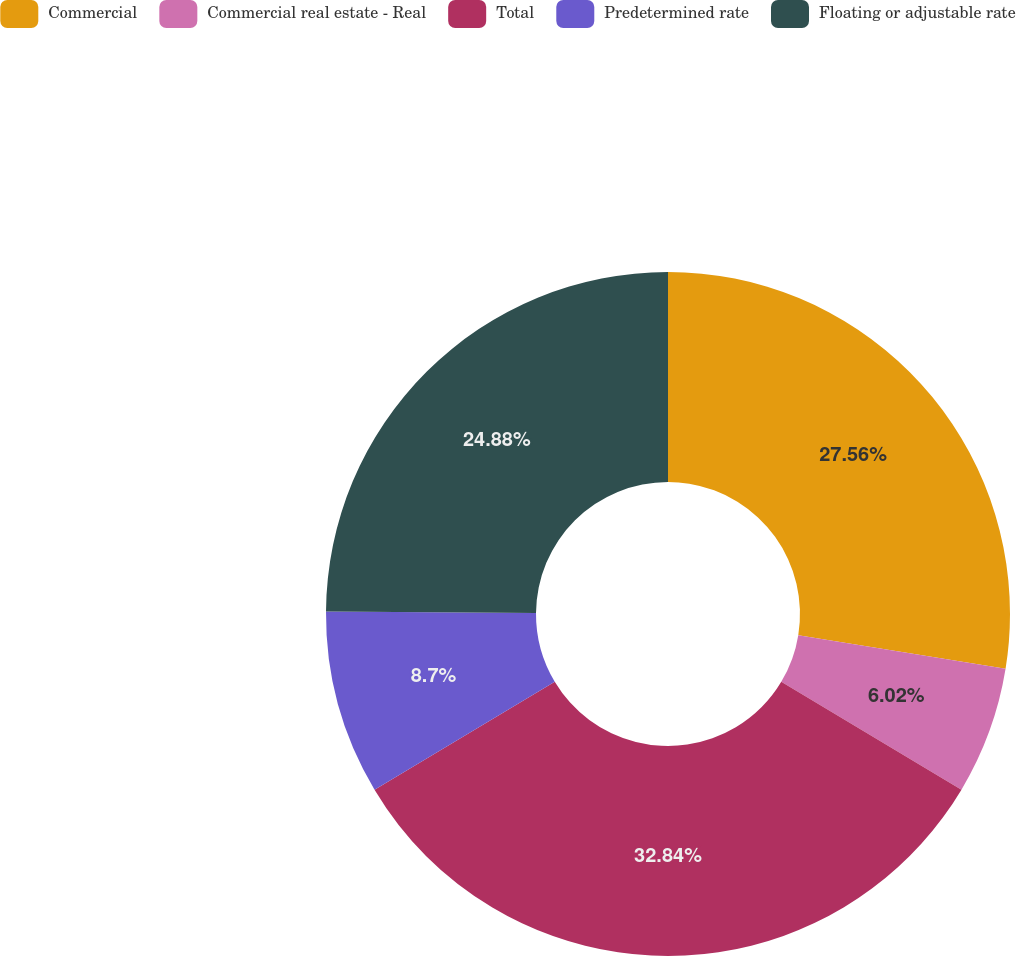<chart> <loc_0><loc_0><loc_500><loc_500><pie_chart><fcel>Commercial<fcel>Commercial real estate - Real<fcel>Total<fcel>Predetermined rate<fcel>Floating or adjustable rate<nl><fcel>27.56%<fcel>6.02%<fcel>32.83%<fcel>8.7%<fcel>24.88%<nl></chart> 